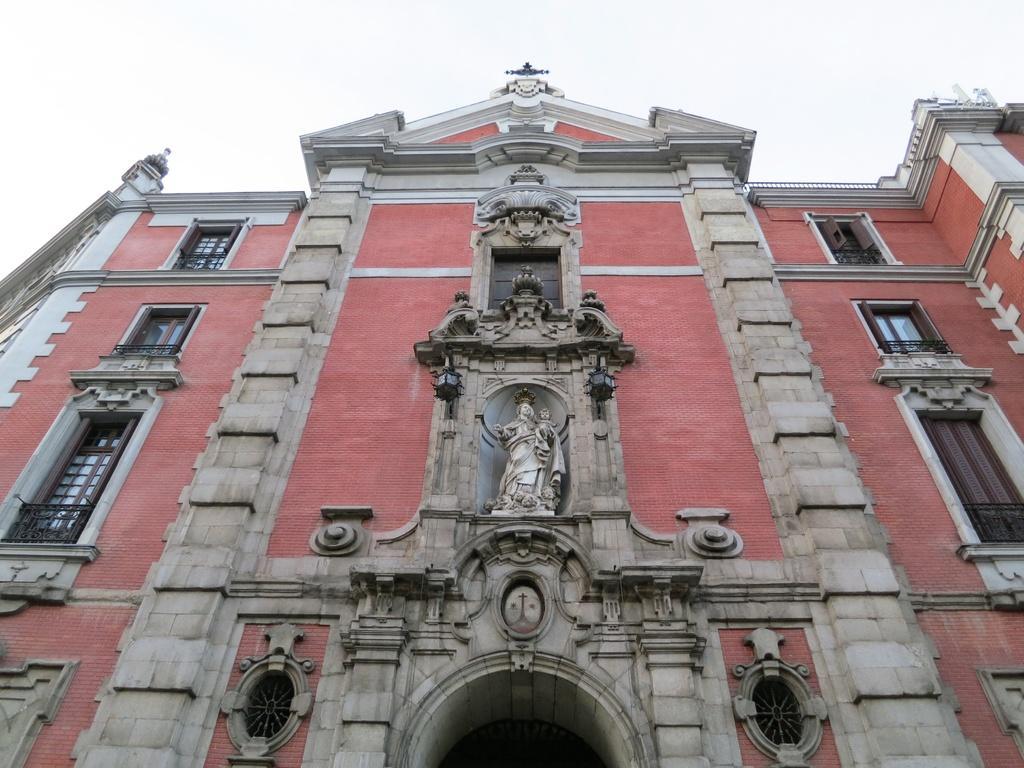Can you describe this image briefly? In this image I can see a huge building which is cream, brown and pink in color. I can see a statue and few windows of the building. In the background I can see the sky. 